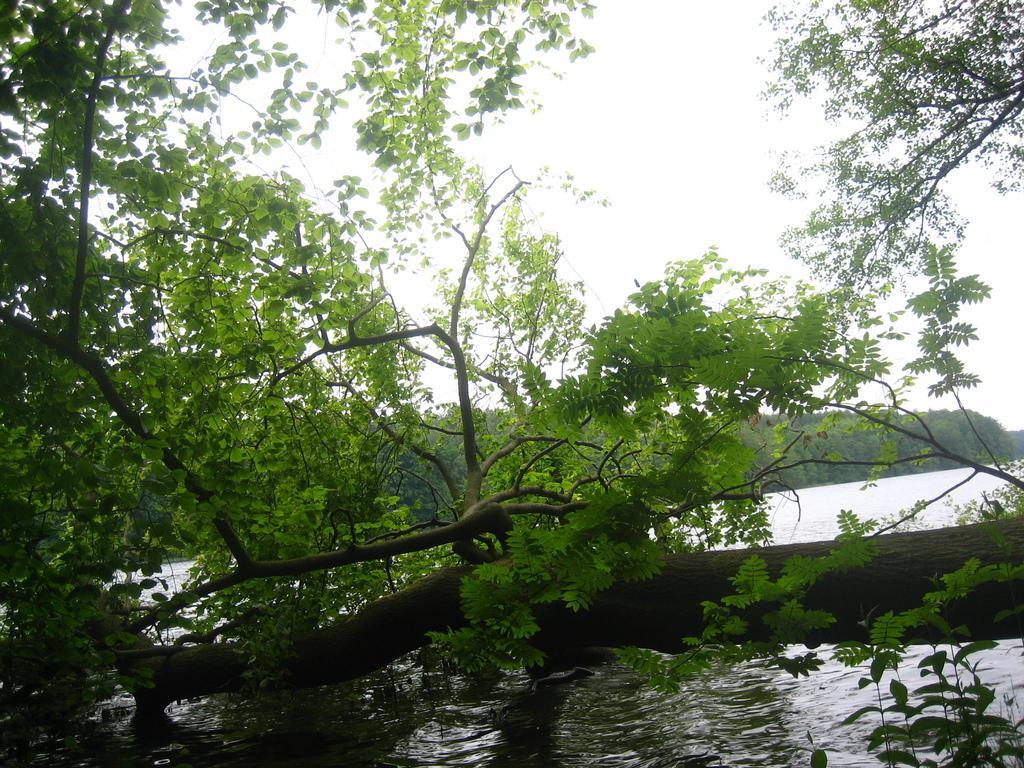How would you summarize this image in a sentence or two? In this image we can see trees, sky and water. 